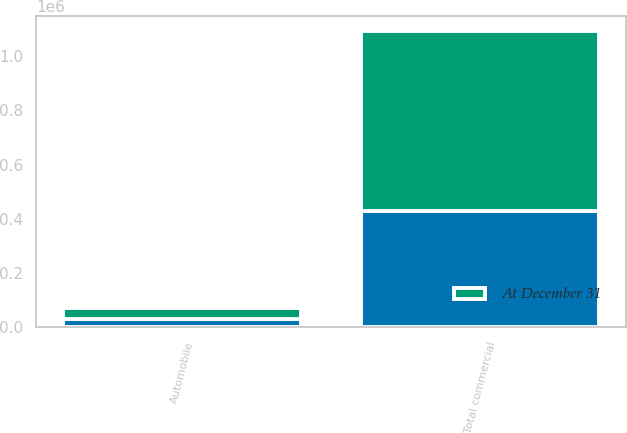Convert chart to OTSL. <chart><loc_0><loc_0><loc_500><loc_500><stacked_bar_chart><ecel><fcel>Total commercial<fcel>Automobile<nl><fcel>nan<fcel>428358<fcel>31053<nl><fcel>At December 31<fcel>664073<fcel>38282<nl></chart> 